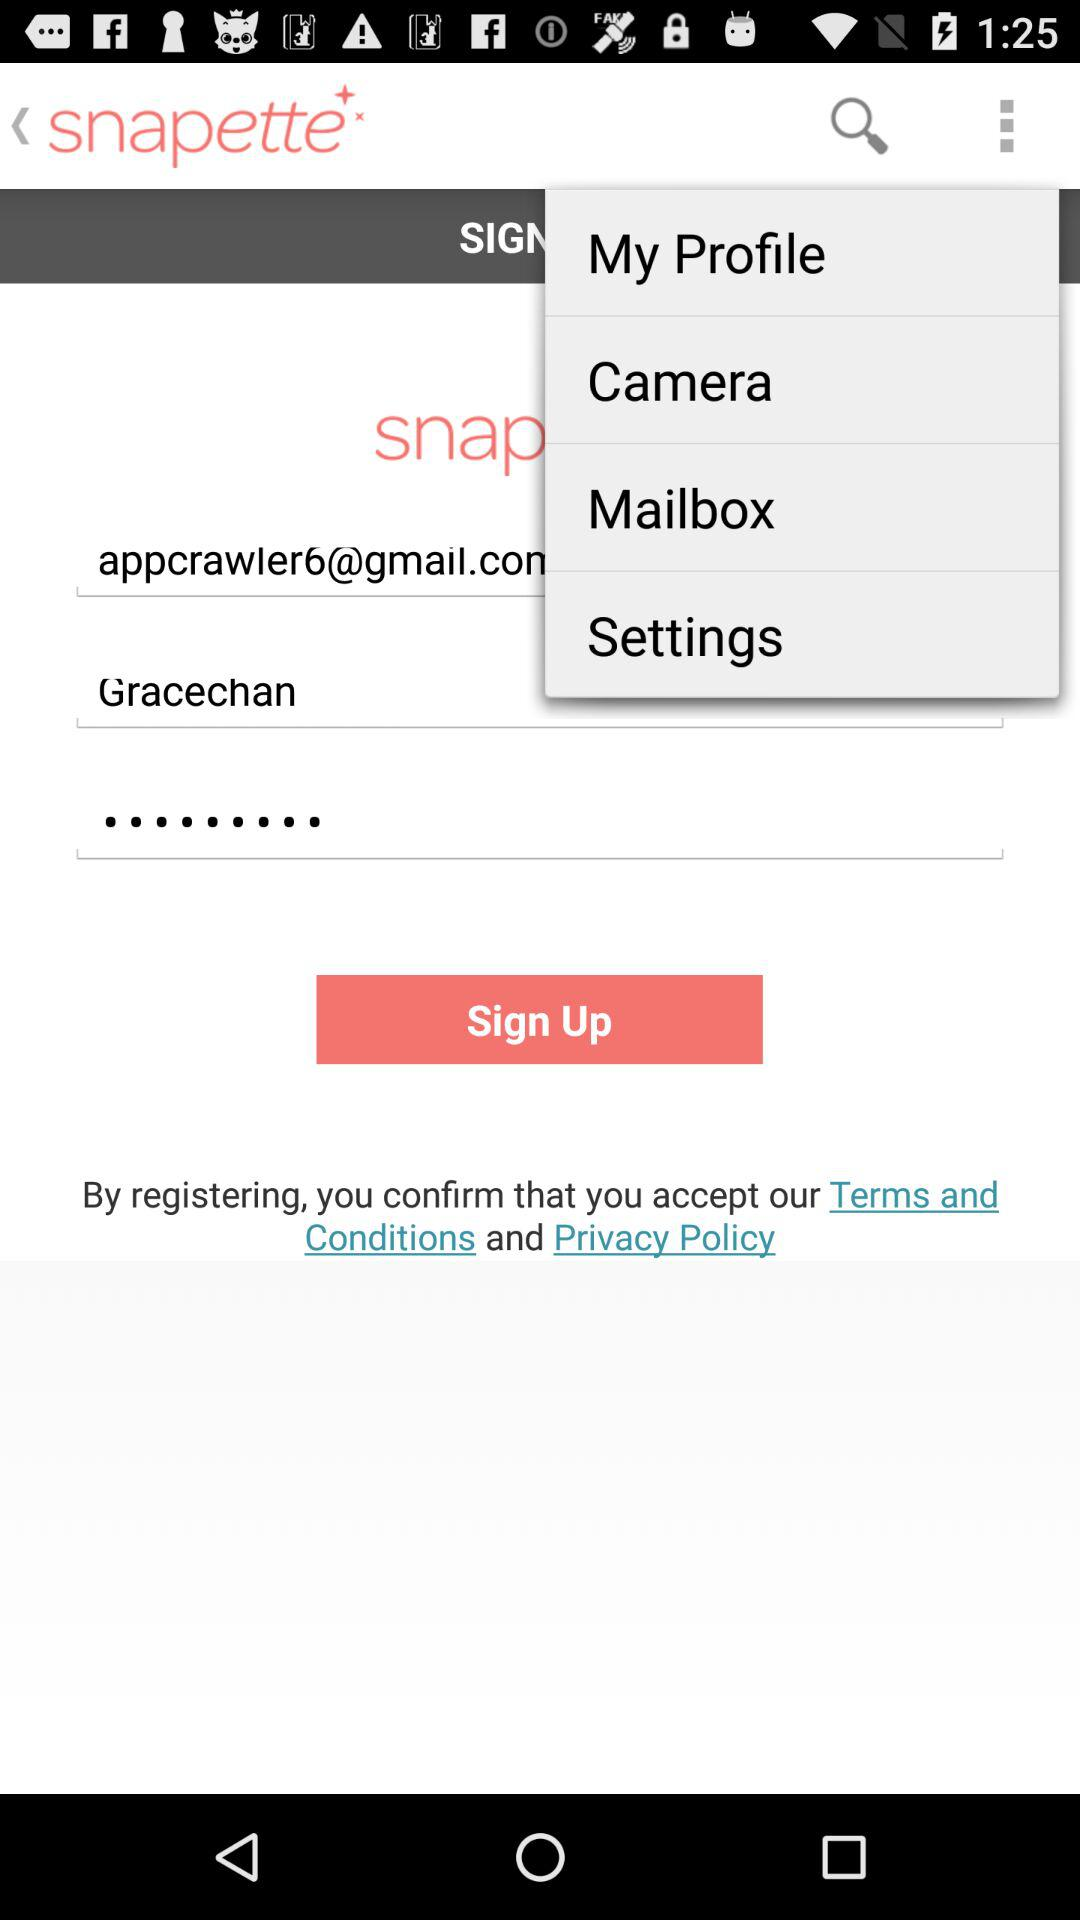What is an email address? The email address is appcrawler6@gmail.com. 